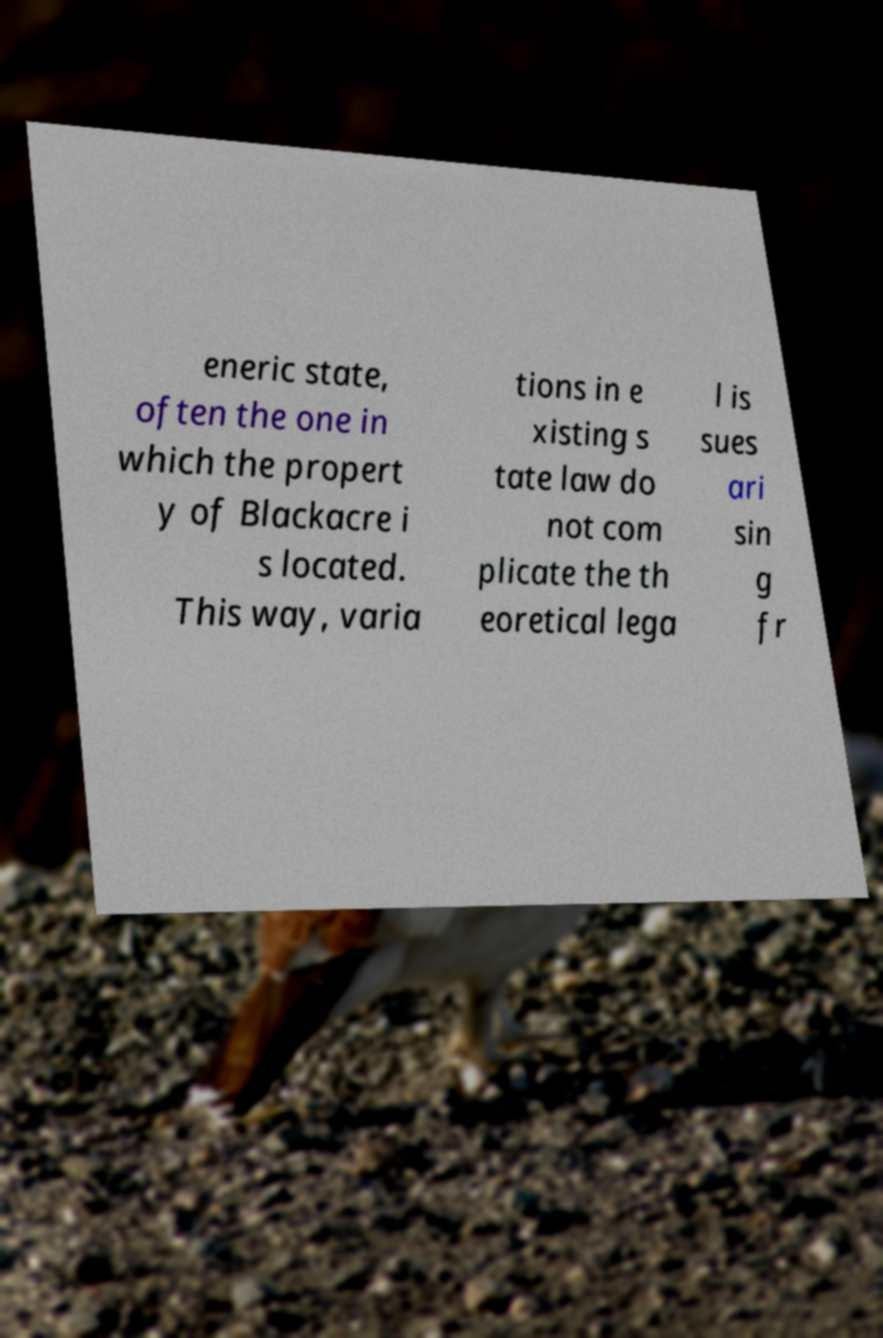I need the written content from this picture converted into text. Can you do that? eneric state, often the one in which the propert y of Blackacre i s located. This way, varia tions in e xisting s tate law do not com plicate the th eoretical lega l is sues ari sin g fr 